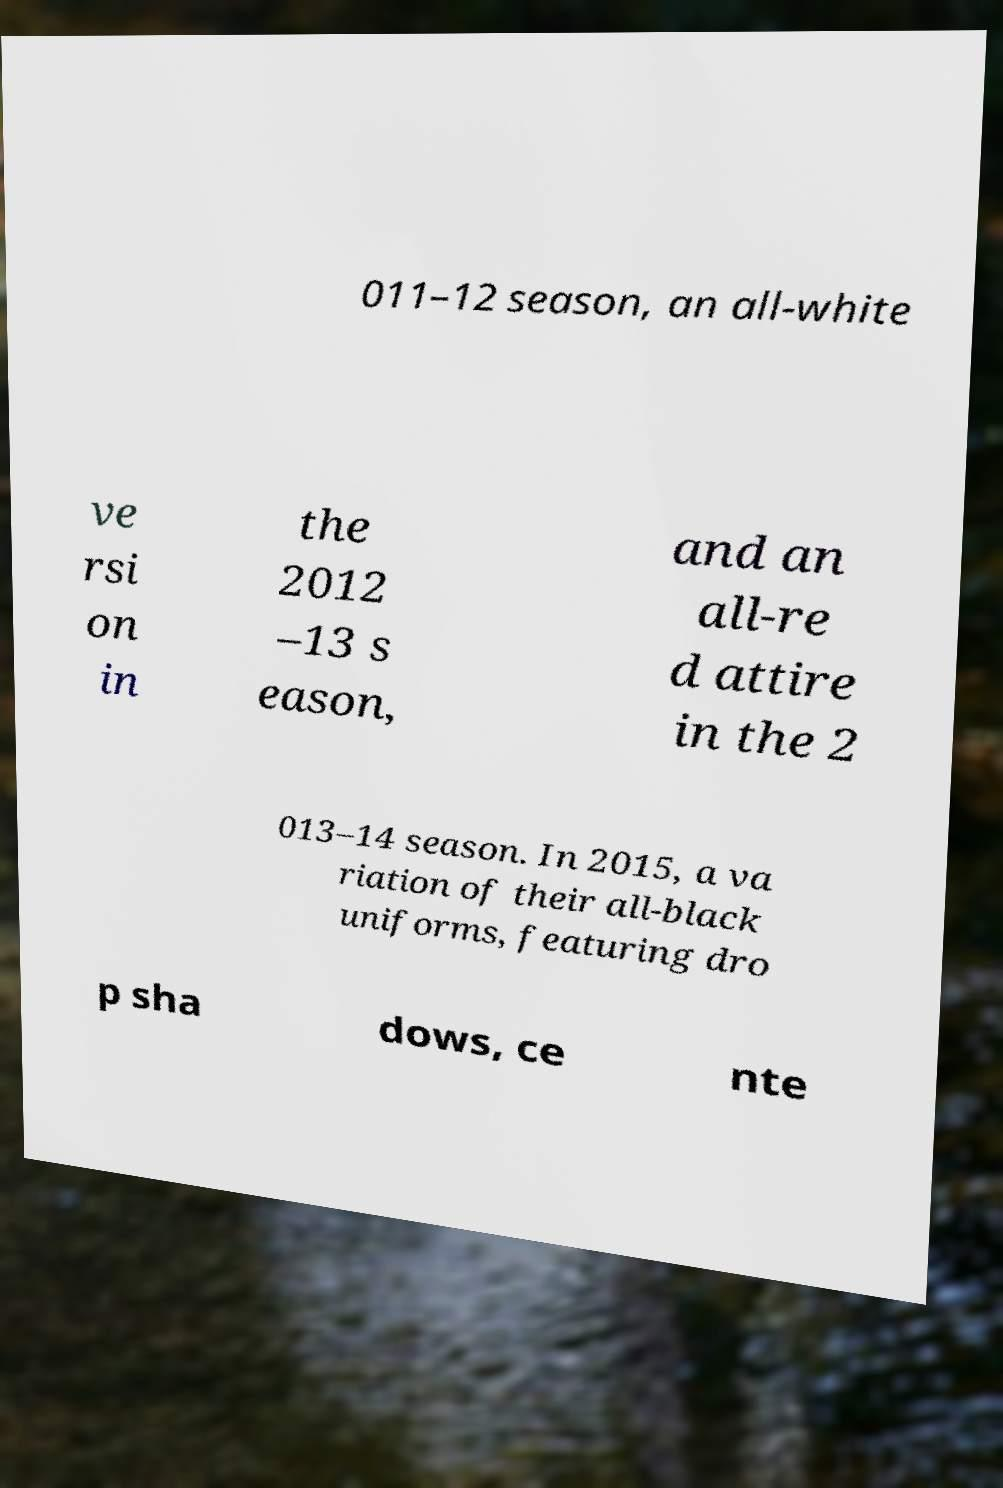Could you extract and type out the text from this image? 011–12 season, an all-white ve rsi on in the 2012 –13 s eason, and an all-re d attire in the 2 013–14 season. In 2015, a va riation of their all-black uniforms, featuring dro p sha dows, ce nte 